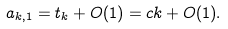Convert formula to latex. <formula><loc_0><loc_0><loc_500><loc_500>a _ { k , 1 } = t _ { k } + O ( 1 ) = c k + O ( 1 ) .</formula> 